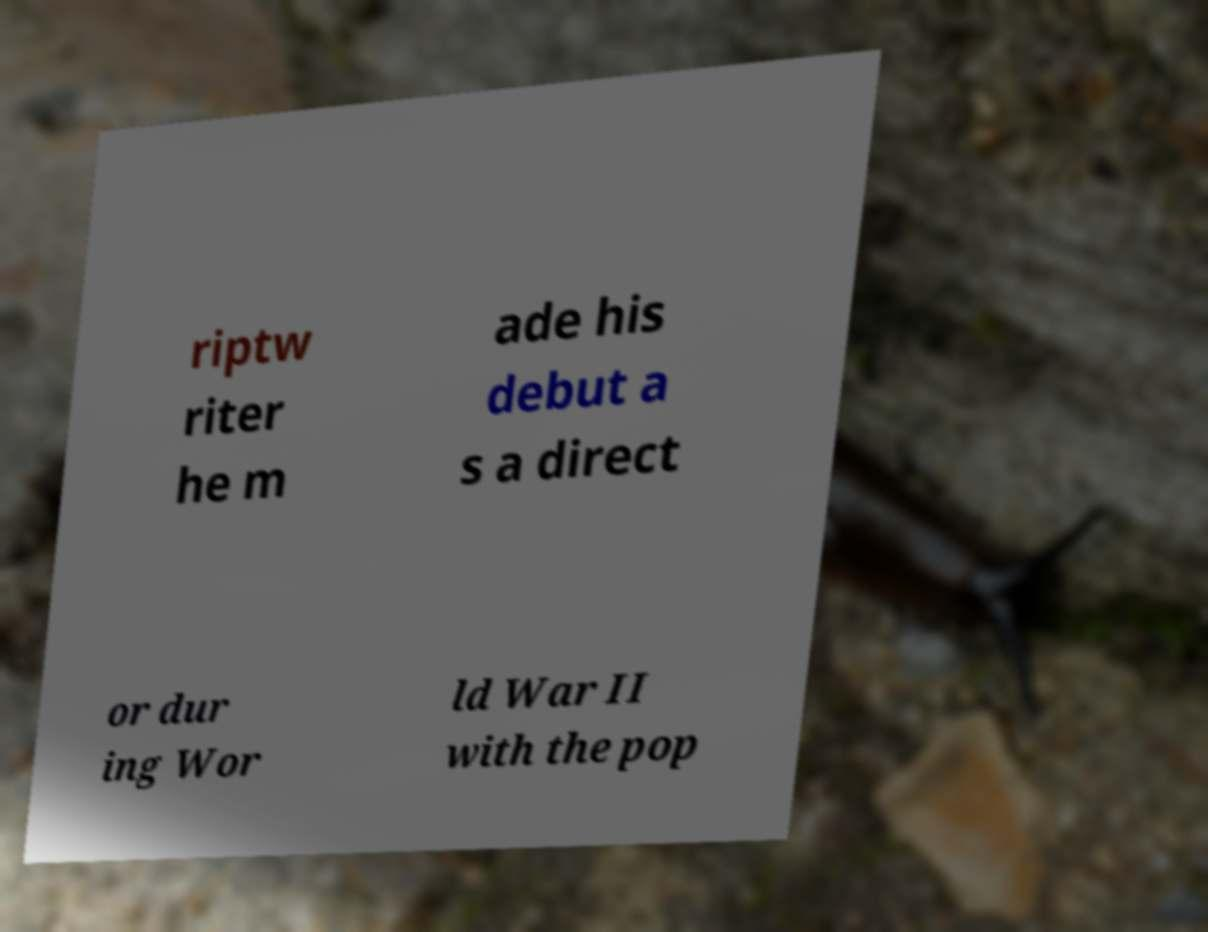Please read and relay the text visible in this image. What does it say? riptw riter he m ade his debut a s a direct or dur ing Wor ld War II with the pop 